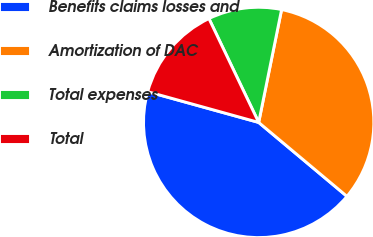Convert chart to OTSL. <chart><loc_0><loc_0><loc_500><loc_500><pie_chart><fcel>Benefits claims losses and<fcel>Amortization of DAC<fcel>Total expenses<fcel>Total<nl><fcel>43.21%<fcel>32.91%<fcel>10.3%<fcel>13.59%<nl></chart> 